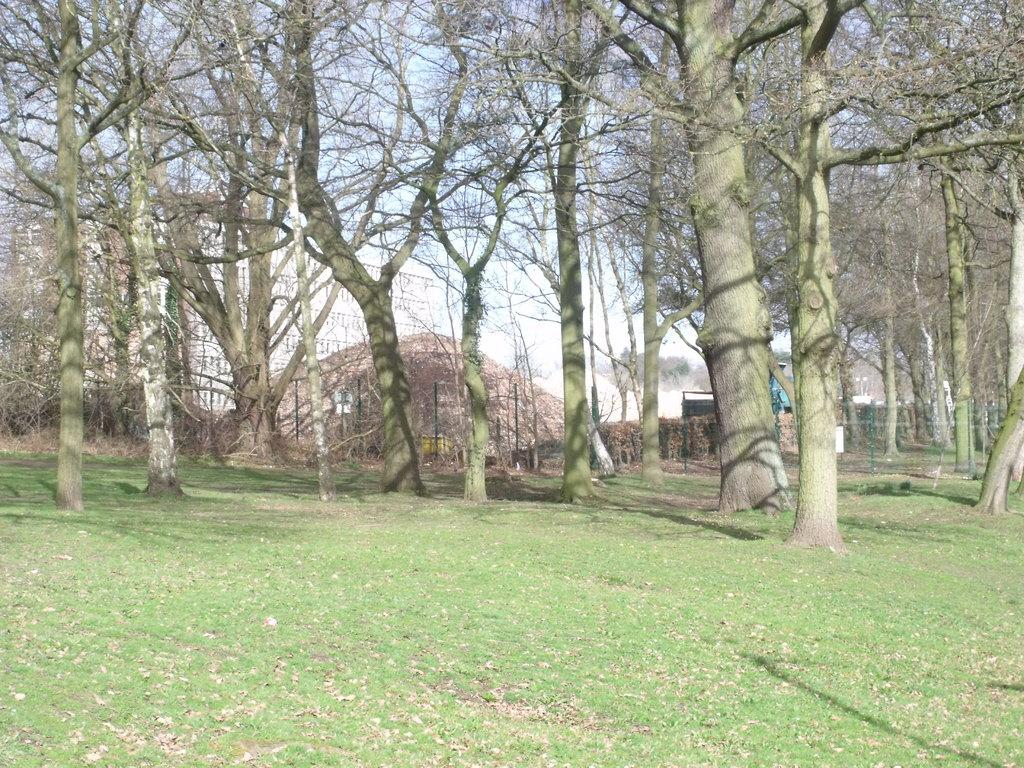What type of vegetation can be seen in the image? There are trees in the image. What is visible in the background of the image? There is a building in the background of the image. What is visible at the top of the image? The sky is visible at the top of the image. What type of ground surface is present at the bottom of the image? There is grass at the bottom of the image. What type of pie is being served on the grass in the image? There is no pie present in the image; it features trees, a building, the sky, and grass. Can you identify any quartz rocks in the image? There are no quartz rocks visible in the image. 